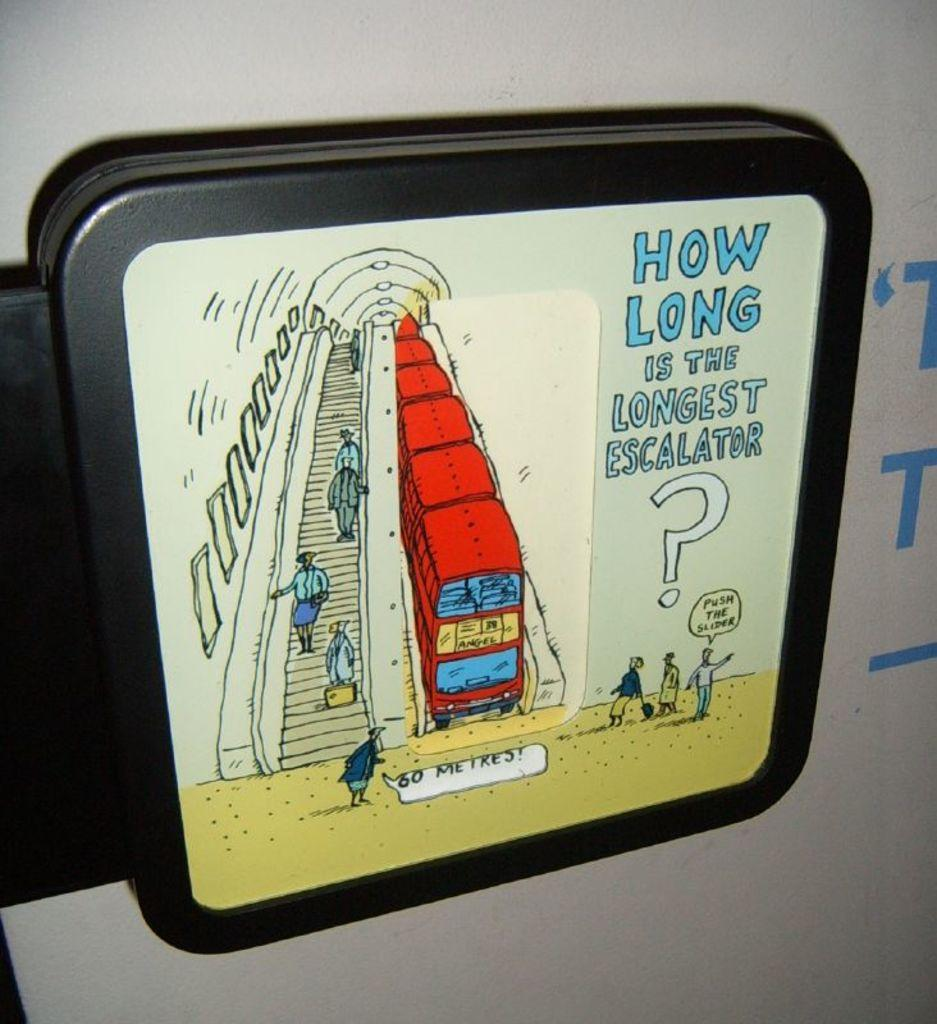What is the main object in the image? There is a blackboard in the image. Is there anything on the blackboard? Yes, there is a sticker on the blackboard. What is depicted on the sticker? The sticker contains an image of an escalator. How many bags are hanging from the escalator in the image? There are no bags or escalators present in the image; it only features a sticker with an image of an escalator on a blackboard. 